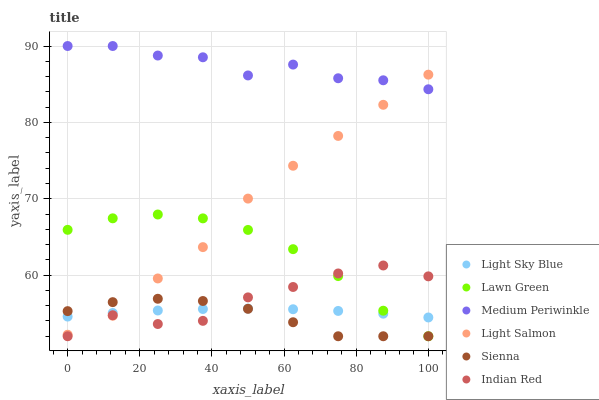Does Sienna have the minimum area under the curve?
Answer yes or no. Yes. Does Medium Periwinkle have the maximum area under the curve?
Answer yes or no. Yes. Does Light Salmon have the minimum area under the curve?
Answer yes or no. No. Does Light Salmon have the maximum area under the curve?
Answer yes or no. No. Is Light Sky Blue the smoothest?
Answer yes or no. Yes. Is Medium Periwinkle the roughest?
Answer yes or no. Yes. Is Light Salmon the smoothest?
Answer yes or no. No. Is Light Salmon the roughest?
Answer yes or no. No. Does Lawn Green have the lowest value?
Answer yes or no. Yes. Does Light Salmon have the lowest value?
Answer yes or no. No. Does Medium Periwinkle have the highest value?
Answer yes or no. Yes. Does Light Salmon have the highest value?
Answer yes or no. No. Is Sienna less than Medium Periwinkle?
Answer yes or no. Yes. Is Medium Periwinkle greater than Lawn Green?
Answer yes or no. Yes. Does Lawn Green intersect Indian Red?
Answer yes or no. Yes. Is Lawn Green less than Indian Red?
Answer yes or no. No. Is Lawn Green greater than Indian Red?
Answer yes or no. No. Does Sienna intersect Medium Periwinkle?
Answer yes or no. No. 